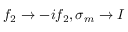<formula> <loc_0><loc_0><loc_500><loc_500>f _ { 2 } \rightarrow - i f _ { 2 } , \sigma _ { m } \rightarrow I</formula> 